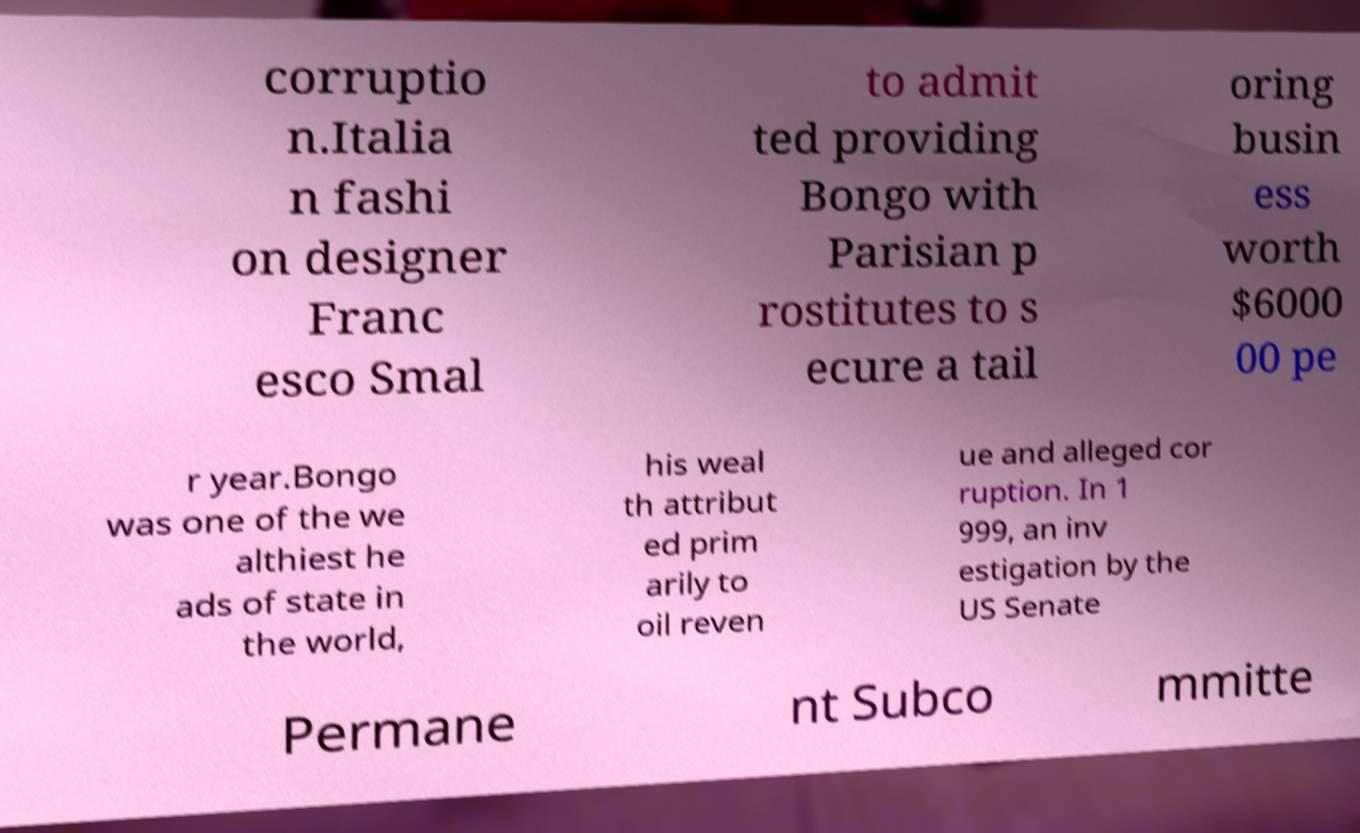Could you assist in decoding the text presented in this image and type it out clearly? corruptio n.Italia n fashi on designer Franc esco Smal to admit ted providing Bongo with Parisian p rostitutes to s ecure a tail oring busin ess worth $6000 00 pe r year.Bongo was one of the we althiest he ads of state in the world, his weal th attribut ed prim arily to oil reven ue and alleged cor ruption. In 1 999, an inv estigation by the US Senate Permane nt Subco mmitte 